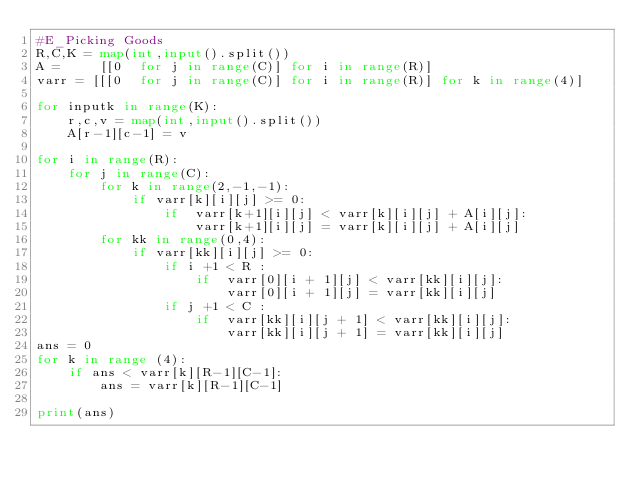Convert code to text. <code><loc_0><loc_0><loc_500><loc_500><_Python_>#E_Picking Goods
R,C,K = map(int,input().split())
A =     [[0  for j in range(C)] for i in range(R)]
varr = [[[0  for j in range(C)] for i in range(R)] for k in range(4)]

for inputk in range(K):
    r,c,v = map(int,input().split())
    A[r-1][c-1] = v

for i in range(R):  
    for j in range(C):
        for k in range(2,-1,-1):
            if varr[k][i][j] >= 0:
                if  varr[k+1][i][j] < varr[k][i][j] + A[i][j]:
                    varr[k+1][i][j] = varr[k][i][j] + A[i][j]
        for kk in range(0,4):
            if varr[kk][i][j] >= 0:
                if i +1 < R :
                    if  varr[0][i + 1][j] < varr[kk][i][j]:
                        varr[0][i + 1][j] = varr[kk][i][j] 
                if j +1 < C :
                    if  varr[kk][i][j + 1] < varr[kk][i][j]:
                        varr[kk][i][j + 1] = varr[kk][i][j] 
ans = 0
for k in range (4):
    if ans < varr[k][R-1][C-1]:
        ans = varr[k][R-1][C-1]

print(ans)
</code> 